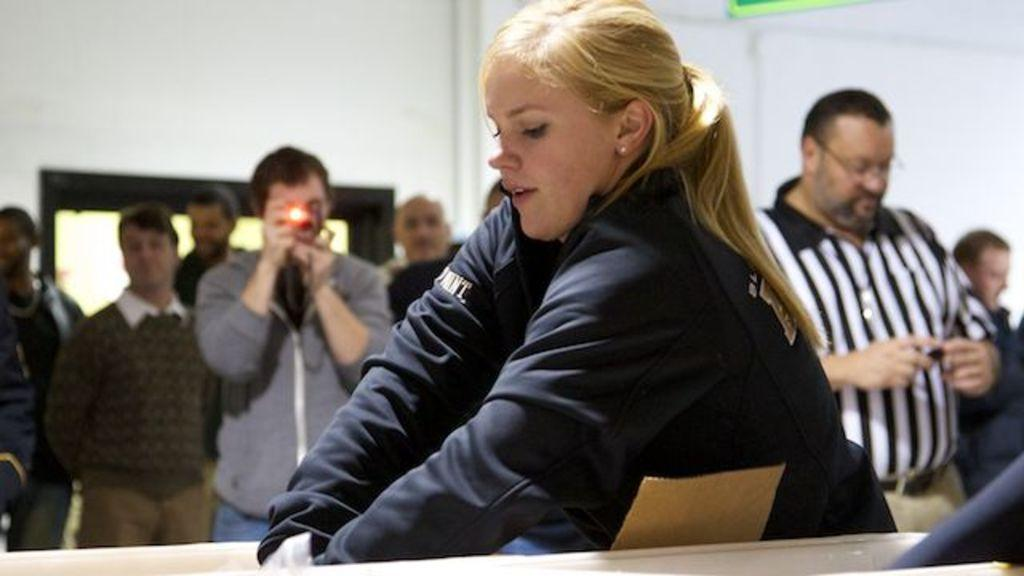What is the main subject of the image? There is a woman in the image. What can be observed about the woman's appearance? The woman is wearing clothes and has ear studs. Are there any other people in the image? Yes, there are other people in the image. What can be said about the other people's attire? The other people are wearing clothes. What is the person holding in the image? There is a person holding a camera in the image. What can be seen in the background of the image? There is a wall visible in the image. What type of zephyr can be seen blowing through the woman's hair in the image? There is no zephyr present in the image, and therefore no such activity can be observed. 